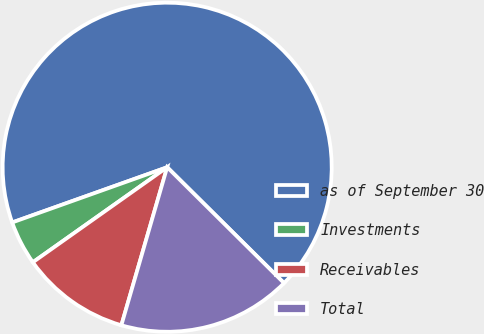<chart> <loc_0><loc_0><loc_500><loc_500><pie_chart><fcel>as of September 30<fcel>Investments<fcel>Receivables<fcel>Total<nl><fcel>67.88%<fcel>4.35%<fcel>10.71%<fcel>17.06%<nl></chart> 